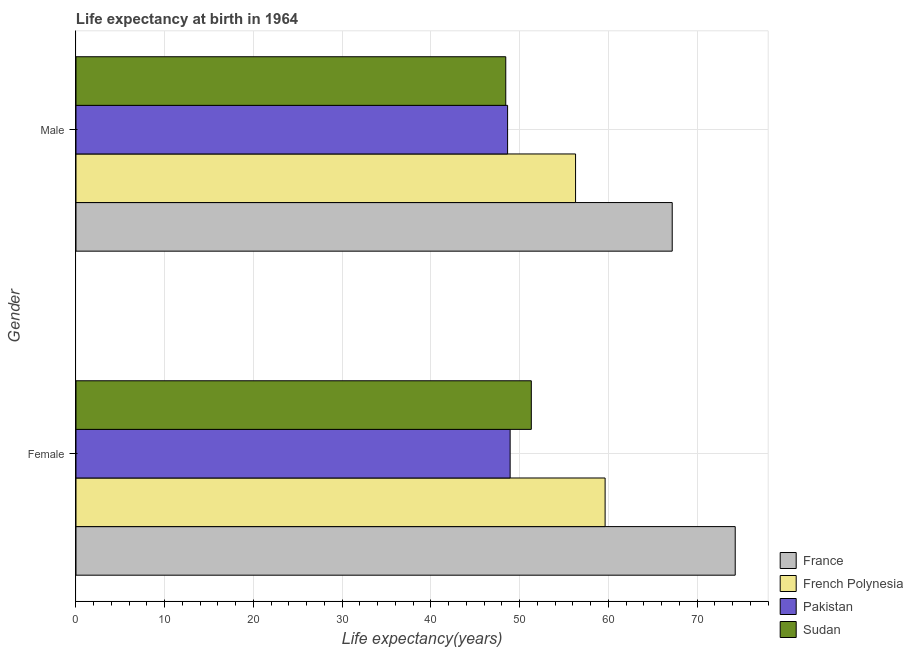How many different coloured bars are there?
Keep it short and to the point. 4. How many groups of bars are there?
Provide a short and direct response. 2. Are the number of bars per tick equal to the number of legend labels?
Your answer should be compact. Yes. Are the number of bars on each tick of the Y-axis equal?
Offer a terse response. Yes. How many bars are there on the 1st tick from the top?
Offer a very short reply. 4. How many bars are there on the 1st tick from the bottom?
Ensure brevity in your answer.  4. What is the life expectancy(female) in Sudan?
Give a very brief answer. 51.32. Across all countries, what is the maximum life expectancy(female)?
Your answer should be very brief. 74.3. Across all countries, what is the minimum life expectancy(female)?
Give a very brief answer. 48.93. In which country was the life expectancy(female) maximum?
Offer a very short reply. France. In which country was the life expectancy(male) minimum?
Your answer should be compact. Sudan. What is the total life expectancy(male) in the graph?
Your answer should be compact. 220.59. What is the difference between the life expectancy(female) in Pakistan and that in Sudan?
Keep it short and to the point. -2.39. What is the difference between the life expectancy(female) in Sudan and the life expectancy(male) in France?
Ensure brevity in your answer.  -15.88. What is the average life expectancy(male) per country?
Ensure brevity in your answer.  55.15. What is the difference between the life expectancy(female) and life expectancy(male) in Pakistan?
Offer a terse response. 0.29. In how many countries, is the life expectancy(male) greater than 46 years?
Your response must be concise. 4. What is the ratio of the life expectancy(male) in Pakistan to that in Sudan?
Provide a succinct answer. 1. Is the life expectancy(male) in French Polynesia less than that in France?
Ensure brevity in your answer.  Yes. In how many countries, is the life expectancy(male) greater than the average life expectancy(male) taken over all countries?
Keep it short and to the point. 2. What does the 3rd bar from the top in Female represents?
Keep it short and to the point. French Polynesia. What does the 2nd bar from the bottom in Male represents?
Your answer should be very brief. French Polynesia. Does the graph contain any zero values?
Offer a very short reply. No. Does the graph contain grids?
Your answer should be compact. Yes. Where does the legend appear in the graph?
Your answer should be very brief. Bottom right. What is the title of the graph?
Your answer should be very brief. Life expectancy at birth in 1964. What is the label or title of the X-axis?
Ensure brevity in your answer.  Life expectancy(years). What is the Life expectancy(years) of France in Female?
Provide a short and direct response. 74.3. What is the Life expectancy(years) of French Polynesia in Female?
Ensure brevity in your answer.  59.64. What is the Life expectancy(years) in Pakistan in Female?
Keep it short and to the point. 48.93. What is the Life expectancy(years) in Sudan in Female?
Ensure brevity in your answer.  51.32. What is the Life expectancy(years) of France in Male?
Provide a succinct answer. 67.2. What is the Life expectancy(years) in French Polynesia in Male?
Keep it short and to the point. 56.3. What is the Life expectancy(years) of Pakistan in Male?
Provide a short and direct response. 48.65. What is the Life expectancy(years) of Sudan in Male?
Your answer should be compact. 48.44. Across all Gender, what is the maximum Life expectancy(years) in France?
Your answer should be compact. 74.3. Across all Gender, what is the maximum Life expectancy(years) of French Polynesia?
Make the answer very short. 59.64. Across all Gender, what is the maximum Life expectancy(years) of Pakistan?
Give a very brief answer. 48.93. Across all Gender, what is the maximum Life expectancy(years) in Sudan?
Make the answer very short. 51.32. Across all Gender, what is the minimum Life expectancy(years) in France?
Provide a succinct answer. 67.2. Across all Gender, what is the minimum Life expectancy(years) in French Polynesia?
Offer a terse response. 56.3. Across all Gender, what is the minimum Life expectancy(years) of Pakistan?
Give a very brief answer. 48.65. Across all Gender, what is the minimum Life expectancy(years) in Sudan?
Your answer should be compact. 48.44. What is the total Life expectancy(years) of France in the graph?
Your answer should be very brief. 141.5. What is the total Life expectancy(years) of French Polynesia in the graph?
Your response must be concise. 115.94. What is the total Life expectancy(years) of Pakistan in the graph?
Offer a very short reply. 97.58. What is the total Life expectancy(years) of Sudan in the graph?
Offer a terse response. 99.76. What is the difference between the Life expectancy(years) in French Polynesia in Female and that in Male?
Give a very brief answer. 3.33. What is the difference between the Life expectancy(years) of Pakistan in Female and that in Male?
Make the answer very short. 0.29. What is the difference between the Life expectancy(years) of Sudan in Female and that in Male?
Your answer should be compact. 2.88. What is the difference between the Life expectancy(years) in France in Female and the Life expectancy(years) in French Polynesia in Male?
Your response must be concise. 18. What is the difference between the Life expectancy(years) in France in Female and the Life expectancy(years) in Pakistan in Male?
Your answer should be very brief. 25.66. What is the difference between the Life expectancy(years) in France in Female and the Life expectancy(years) in Sudan in Male?
Provide a short and direct response. 25.86. What is the difference between the Life expectancy(years) in French Polynesia in Female and the Life expectancy(years) in Pakistan in Male?
Your answer should be compact. 10.99. What is the difference between the Life expectancy(years) in French Polynesia in Female and the Life expectancy(years) in Sudan in Male?
Your answer should be very brief. 11.2. What is the difference between the Life expectancy(years) of Pakistan in Female and the Life expectancy(years) of Sudan in Male?
Provide a short and direct response. 0.49. What is the average Life expectancy(years) in France per Gender?
Offer a terse response. 70.75. What is the average Life expectancy(years) of French Polynesia per Gender?
Your response must be concise. 57.97. What is the average Life expectancy(years) in Pakistan per Gender?
Your answer should be compact. 48.79. What is the average Life expectancy(years) in Sudan per Gender?
Offer a terse response. 49.88. What is the difference between the Life expectancy(years) of France and Life expectancy(years) of French Polynesia in Female?
Provide a short and direct response. 14.66. What is the difference between the Life expectancy(years) of France and Life expectancy(years) of Pakistan in Female?
Keep it short and to the point. 25.37. What is the difference between the Life expectancy(years) in France and Life expectancy(years) in Sudan in Female?
Your answer should be compact. 22.98. What is the difference between the Life expectancy(years) in French Polynesia and Life expectancy(years) in Pakistan in Female?
Offer a very short reply. 10.7. What is the difference between the Life expectancy(years) of French Polynesia and Life expectancy(years) of Sudan in Female?
Make the answer very short. 8.32. What is the difference between the Life expectancy(years) of Pakistan and Life expectancy(years) of Sudan in Female?
Provide a short and direct response. -2.39. What is the difference between the Life expectancy(years) of France and Life expectancy(years) of French Polynesia in Male?
Provide a short and direct response. 10.89. What is the difference between the Life expectancy(years) of France and Life expectancy(years) of Pakistan in Male?
Keep it short and to the point. 18.55. What is the difference between the Life expectancy(years) in France and Life expectancy(years) in Sudan in Male?
Your answer should be compact. 18.76. What is the difference between the Life expectancy(years) of French Polynesia and Life expectancy(years) of Pakistan in Male?
Keep it short and to the point. 7.66. What is the difference between the Life expectancy(years) in French Polynesia and Life expectancy(years) in Sudan in Male?
Ensure brevity in your answer.  7.87. What is the difference between the Life expectancy(years) of Pakistan and Life expectancy(years) of Sudan in Male?
Your answer should be very brief. 0.21. What is the ratio of the Life expectancy(years) in France in Female to that in Male?
Your response must be concise. 1.11. What is the ratio of the Life expectancy(years) of French Polynesia in Female to that in Male?
Your answer should be compact. 1.06. What is the ratio of the Life expectancy(years) of Pakistan in Female to that in Male?
Your answer should be very brief. 1.01. What is the ratio of the Life expectancy(years) of Sudan in Female to that in Male?
Ensure brevity in your answer.  1.06. What is the difference between the highest and the second highest Life expectancy(years) of French Polynesia?
Offer a terse response. 3.33. What is the difference between the highest and the second highest Life expectancy(years) of Pakistan?
Offer a terse response. 0.29. What is the difference between the highest and the second highest Life expectancy(years) in Sudan?
Keep it short and to the point. 2.88. What is the difference between the highest and the lowest Life expectancy(years) of French Polynesia?
Keep it short and to the point. 3.33. What is the difference between the highest and the lowest Life expectancy(years) in Pakistan?
Offer a terse response. 0.29. What is the difference between the highest and the lowest Life expectancy(years) in Sudan?
Your answer should be compact. 2.88. 